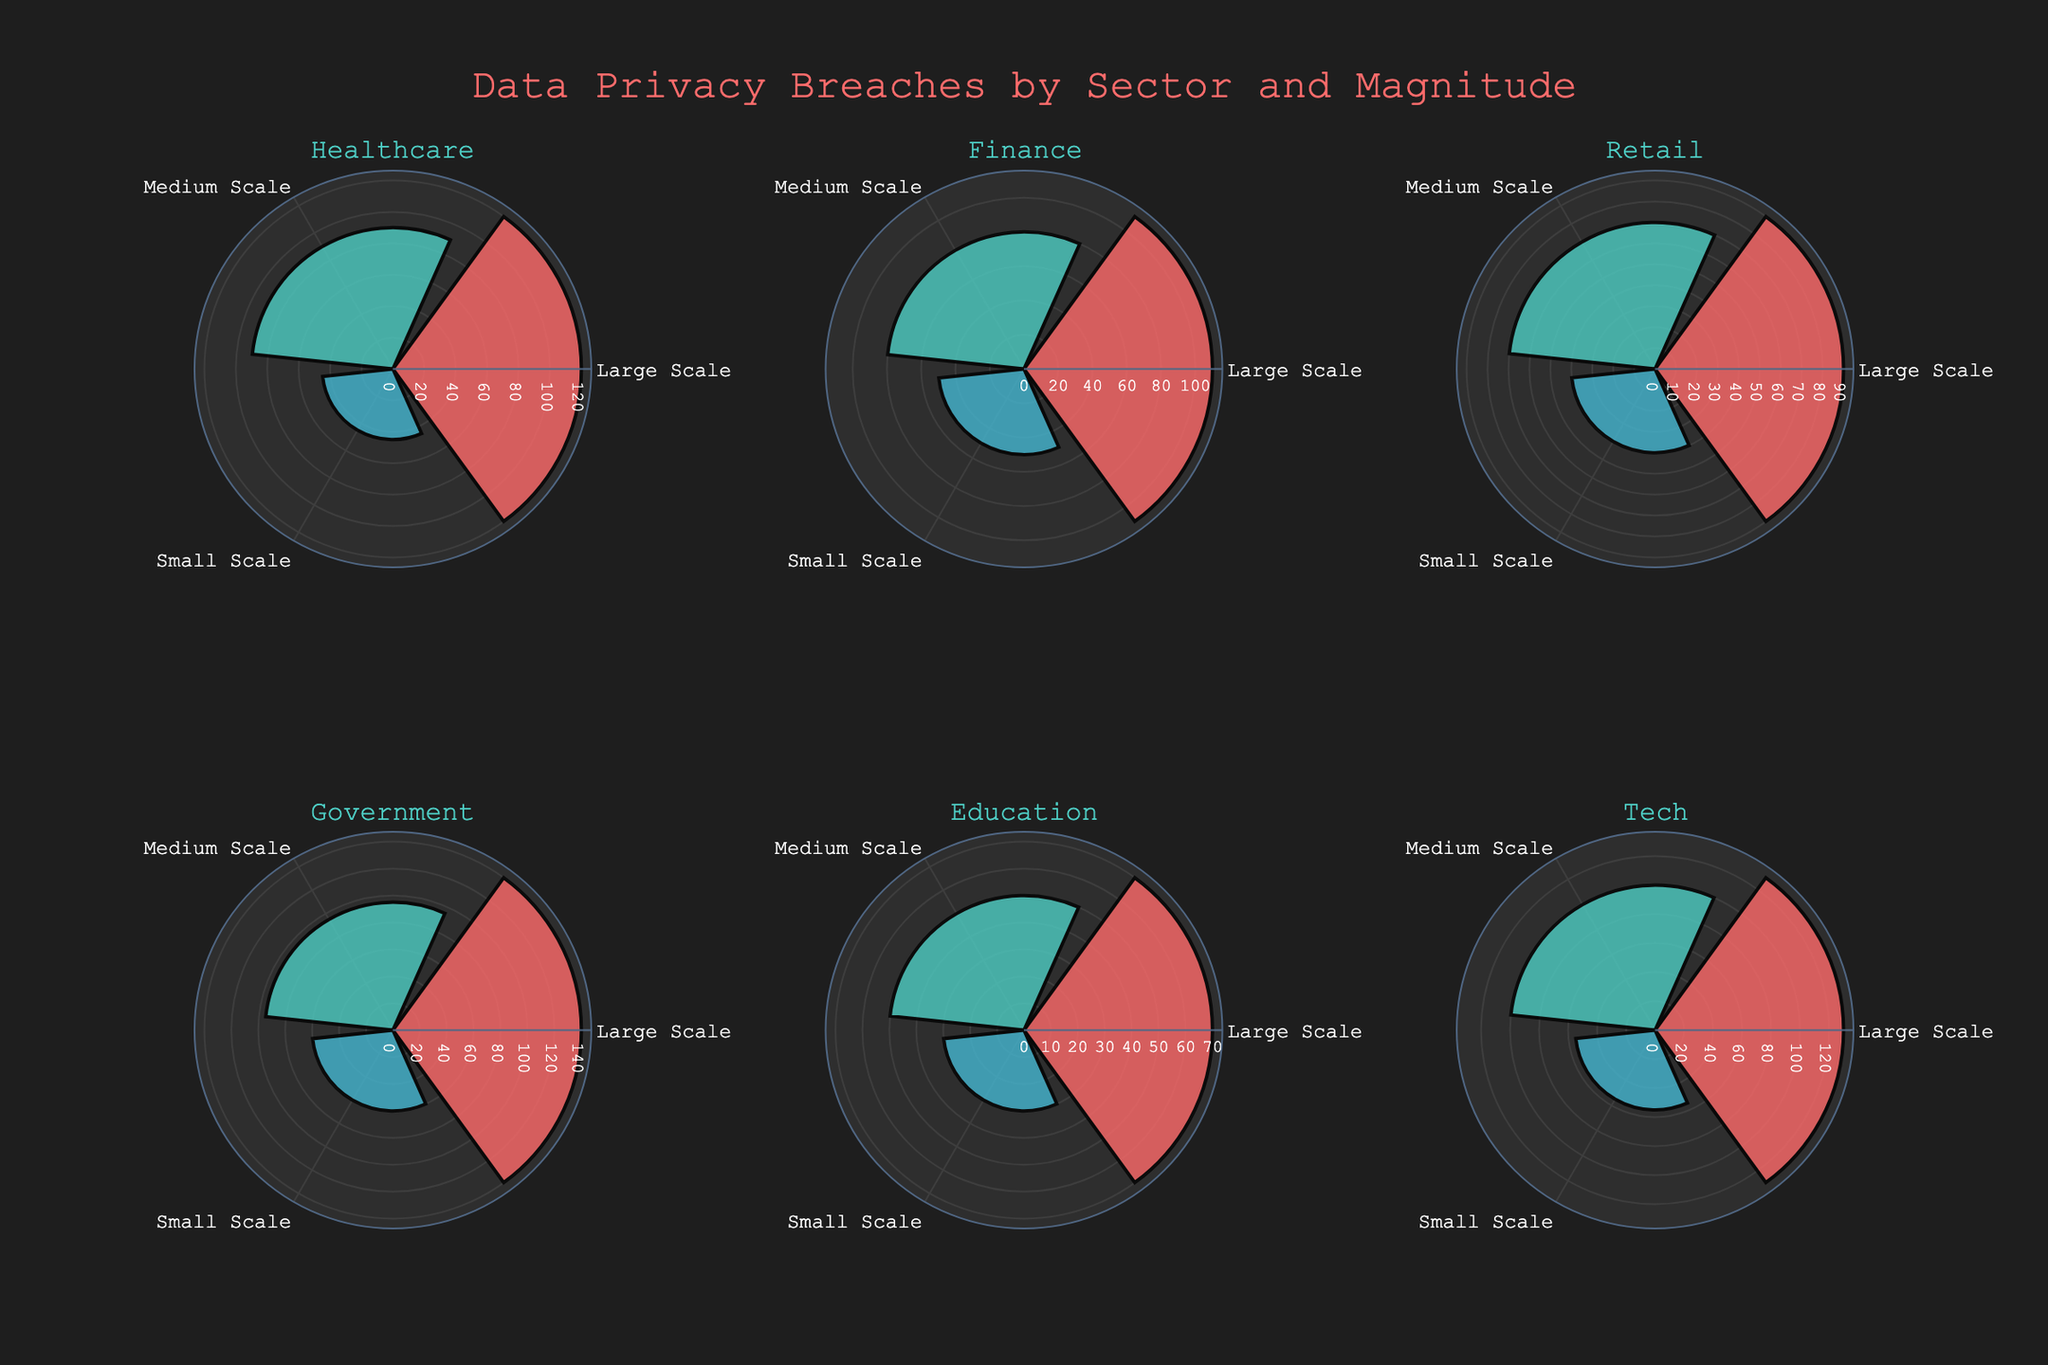What is the title of the figure? The title of the figure is usually placed at the top center and is visually distinct, often larger in size and differently colored.
Answer: Data Privacy Breaches by Sector and Magnitude Which sector has the highest number of large-scale breaches? Look at the bars representing large-scale breaches in each subplot. The bar with the maximum value indicates the sector.
Answer: Government In the retail sector, how many breaches of all types are there in total? Sum the counts of small, medium, and large-scale breaches in the retail sector subplot.
Answer: 200 Which two sectors are displayed in the top row of the figure? Check the labels of the subplots in the top row to identify the sectors.
Answer: Healthcare, Finance What is the difference in the number of small-scale breaches between the healthcare and education sectors? Subtract the number of small-scale breaches in the education sector from the number in the healthcare sector.
Answer: 15 How do the medium-scale breaches in the tech sector compare to those in the government sector? Compare the bar lengths (or counts) of medium-scale breaches in the tech and government sectors. The tech sector has fewer (100 vs. 95).
Answer: Fewer For the finance sector, what is the average count of breaches across small, medium, and large-scale types? Calculate the average by summing the counts of breaches and then dividing by 3.
Answer: 80 Which sector has the smallest number of total breaches? Add the counts of all breach types for each sector and identify the sector with the smallest sum.
Answer: Education Are the color schemes consistent across all sectors for the same breach types? Verify if the same colors are used for large, medium, and small-scale breaches in each sector.
Answer: Yes Which sector has the highest variation in breach types? Find the sector where the differences between the counts of large, medium, and small-scale breaches are the most pronounced.
Answer: Government 